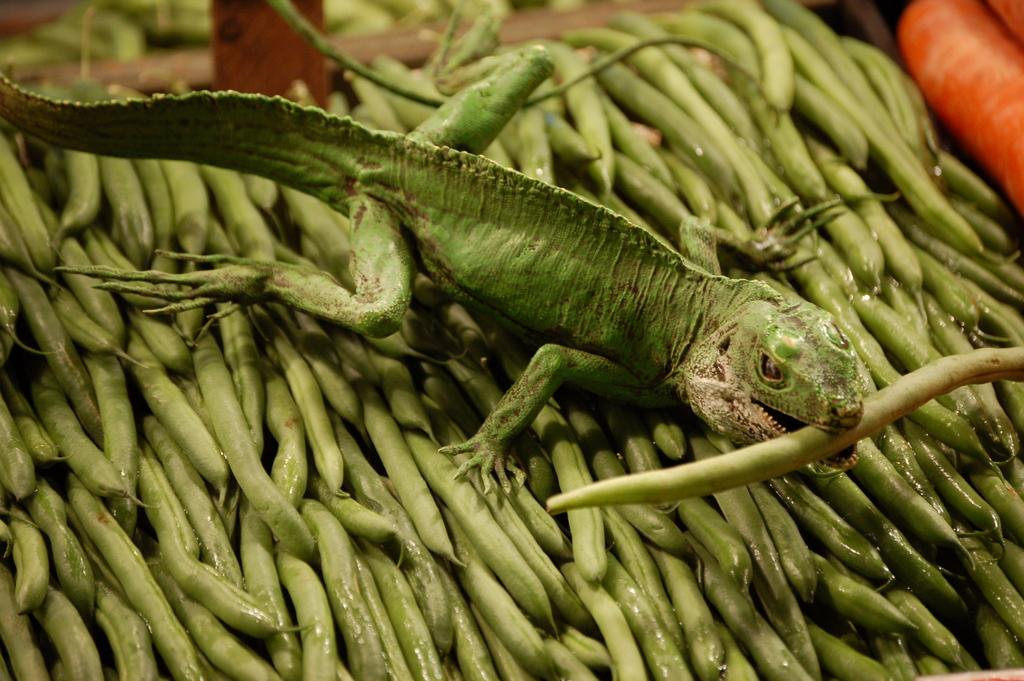What type of animal is in the image? There is a garden lizard in the image. What can be seen at the bottom of the image? There are vegetables at the bottom of the image. What type of leather can be seen in the image? There is no leather present in the image; it features a garden lizard and vegetables. 